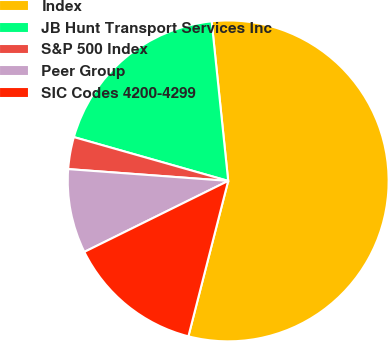Convert chart. <chart><loc_0><loc_0><loc_500><loc_500><pie_chart><fcel>Index<fcel>JB Hunt Transport Services Inc<fcel>S&P 500 Index<fcel>Peer Group<fcel>SIC Codes 4200-4299<nl><fcel>55.63%<fcel>18.95%<fcel>3.23%<fcel>8.47%<fcel>13.71%<nl></chart> 